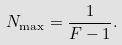Convert formula to latex. <formula><loc_0><loc_0><loc_500><loc_500>N _ { \max } = \frac { 1 } { F - 1 } .</formula> 